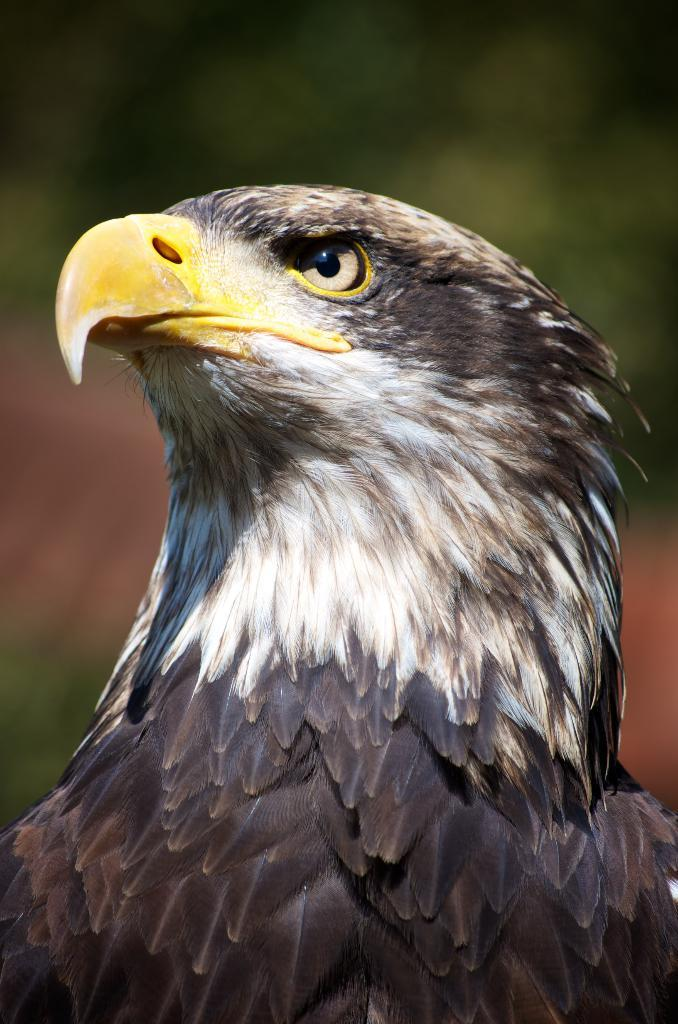What animal is the main subject of the image? There is an eagle in the image. Can you describe the background of the image? The background of the image is blurry. What type of quilt is being used to connect the eagle to its sister in the image? There is no quilt or sister present in the image; it features an eagle with a blurry background. 